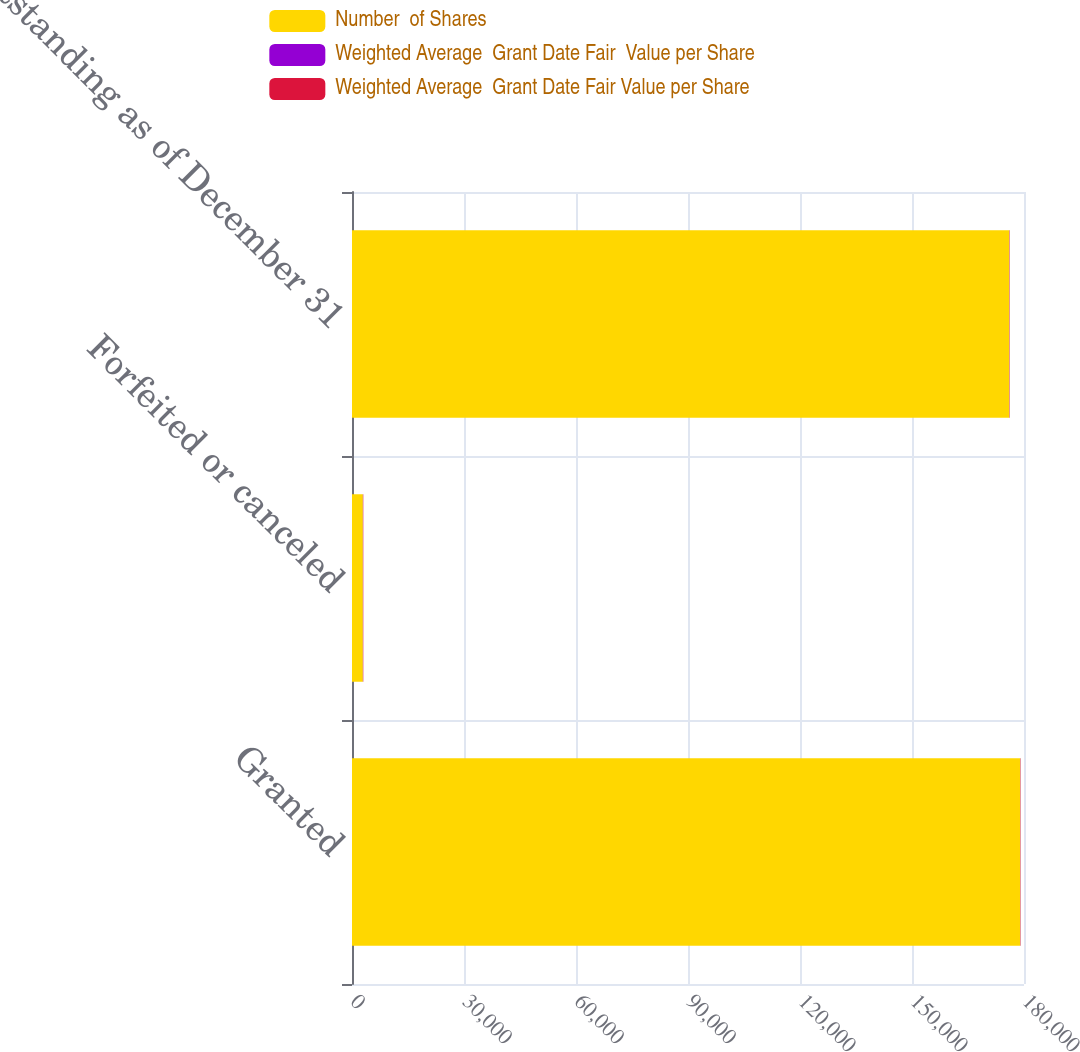Convert chart. <chart><loc_0><loc_0><loc_500><loc_500><stacked_bar_chart><ecel><fcel>Granted<fcel>Forfeited or canceled<fcel>Outstanding as of December 31<nl><fcel>Number  of Shares<fcel>179006<fcel>2915<fcel>176091<nl><fcel>Weighted Average  Grant Date Fair  Value per Share<fcel>58.4<fcel>58.02<fcel>58.41<nl><fcel>Weighted Average  Grant Date Fair Value per Share<fcel>58.4<fcel>58.02<fcel>58.41<nl></chart> 